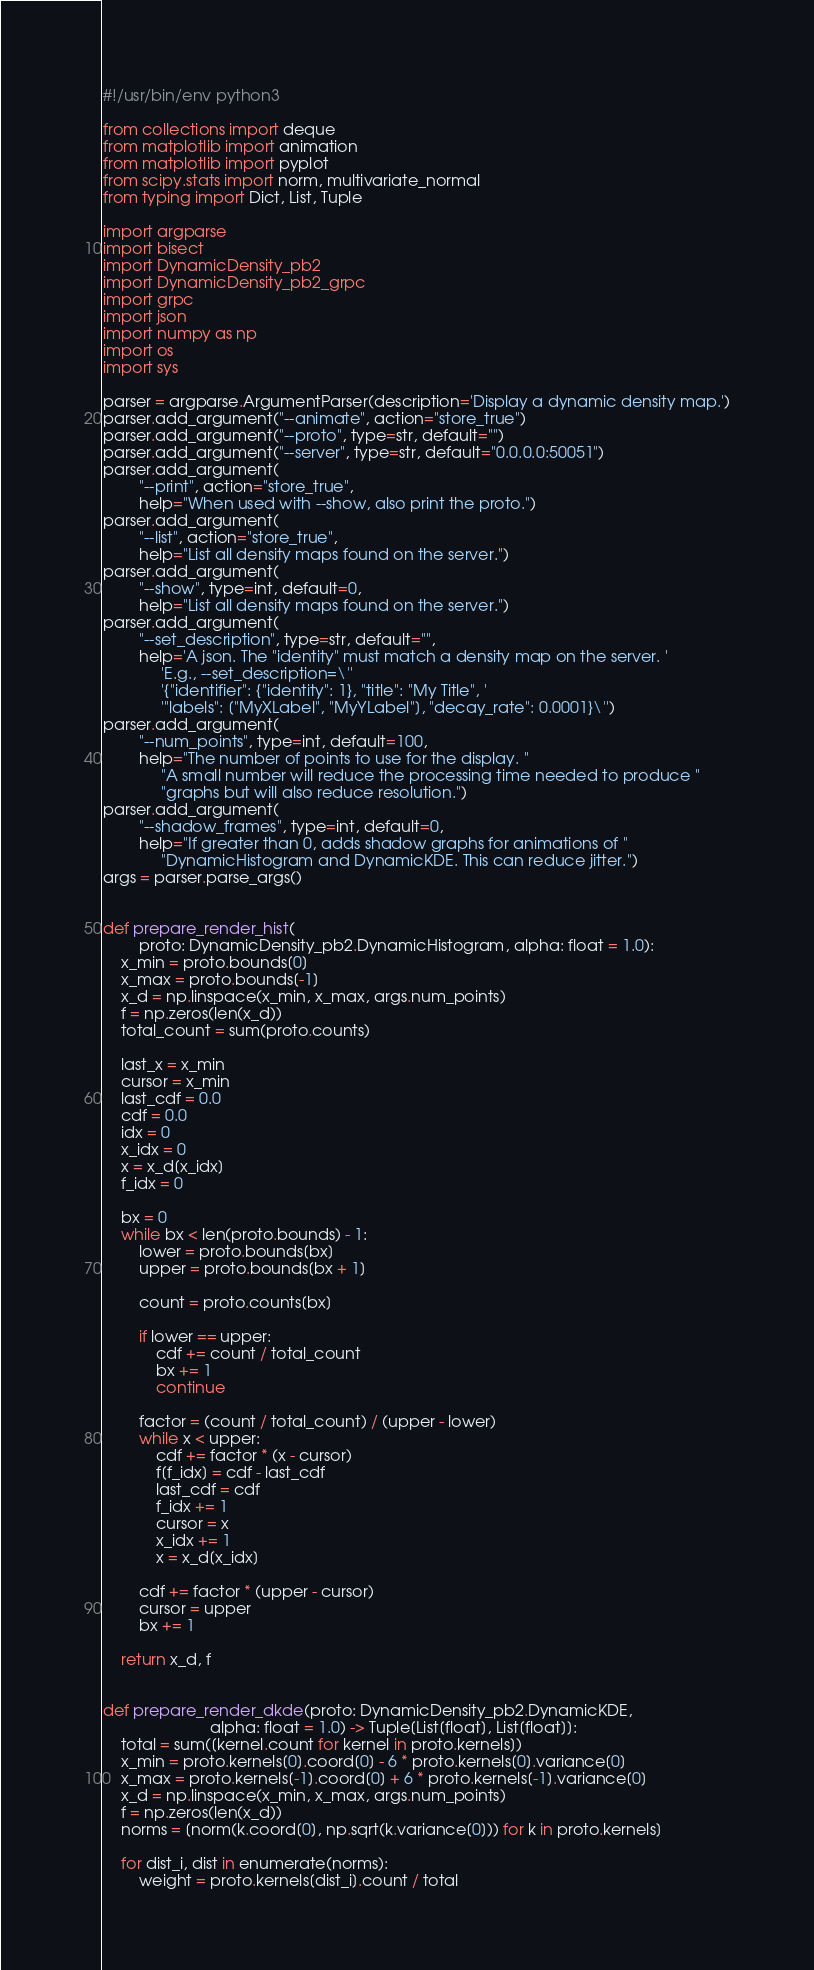<code> <loc_0><loc_0><loc_500><loc_500><_Python_>#!/usr/bin/env python3

from collections import deque
from matplotlib import animation
from matplotlib import pyplot
from scipy.stats import norm, multivariate_normal
from typing import Dict, List, Tuple

import argparse
import bisect
import DynamicDensity_pb2
import DynamicDensity_pb2_grpc
import grpc
import json
import numpy as np
import os
import sys

parser = argparse.ArgumentParser(description='Display a dynamic density map.')
parser.add_argument("--animate", action="store_true")
parser.add_argument("--proto", type=str, default="")
parser.add_argument("--server", type=str, default="0.0.0.0:50051")
parser.add_argument(
        "--print", action="store_true",
        help="When used with --show, also print the proto.")
parser.add_argument(
        "--list", action="store_true",
        help="List all density maps found on the server.")
parser.add_argument(
        "--show", type=int, default=0,
        help="List all density maps found on the server.")
parser.add_argument(
        "--set_description", type=str, default="",
        help='A json. The "identity" must match a density map on the server. '
             'E.g., --set_description=\''
             '{"identifier": {"identity": 1}, "title": "My Title", '
             '"labels": ["MyXLabel", "MyYLabel"], "decay_rate": 0.0001}\'')
parser.add_argument(
        "--num_points", type=int, default=100,
        help="The number of points to use for the display. "
             "A small number will reduce the processing time needed to produce "
             "graphs but will also reduce resolution.")
parser.add_argument(
        "--shadow_frames", type=int, default=0,
        help="If greater than 0, adds shadow graphs for animations of "
             "DynamicHistogram and DynamicKDE. This can reduce jitter.")
args = parser.parse_args()


def prepare_render_hist(
        proto: DynamicDensity_pb2.DynamicHistogram, alpha: float = 1.0):
    x_min = proto.bounds[0]
    x_max = proto.bounds[-1]
    x_d = np.linspace(x_min, x_max, args.num_points)
    f = np.zeros(len(x_d))
    total_count = sum(proto.counts)

    last_x = x_min
    cursor = x_min
    last_cdf = 0.0
    cdf = 0.0
    idx = 0
    x_idx = 0
    x = x_d[x_idx]
    f_idx = 0

    bx = 0
    while bx < len(proto.bounds) - 1:
        lower = proto.bounds[bx]
        upper = proto.bounds[bx + 1]

        count = proto.counts[bx]

        if lower == upper:
            cdf += count / total_count
            bx += 1
            continue

        factor = (count / total_count) / (upper - lower)
        while x < upper:
            cdf += factor * (x - cursor)
            f[f_idx] = cdf - last_cdf
            last_cdf = cdf
            f_idx += 1
            cursor = x
            x_idx += 1
            x = x_d[x_idx]

        cdf += factor * (upper - cursor)
        cursor = upper
        bx += 1

    return x_d, f


def prepare_render_dkde(proto: DynamicDensity_pb2.DynamicKDE,
                        alpha: float = 1.0) -> Tuple[List[float], List[float]]:
    total = sum([kernel.count for kernel in proto.kernels])
    x_min = proto.kernels[0].coord[0] - 6 * proto.kernels[0].variance[0]
    x_max = proto.kernels[-1].coord[0] + 6 * proto.kernels[-1].variance[0]
    x_d = np.linspace(x_min, x_max, args.num_points)
    f = np.zeros(len(x_d))
    norms = [norm(k.coord[0], np.sqrt(k.variance[0])) for k in proto.kernels]

    for dist_i, dist in enumerate(norms):
        weight = proto.kernels[dist_i].count / total</code> 